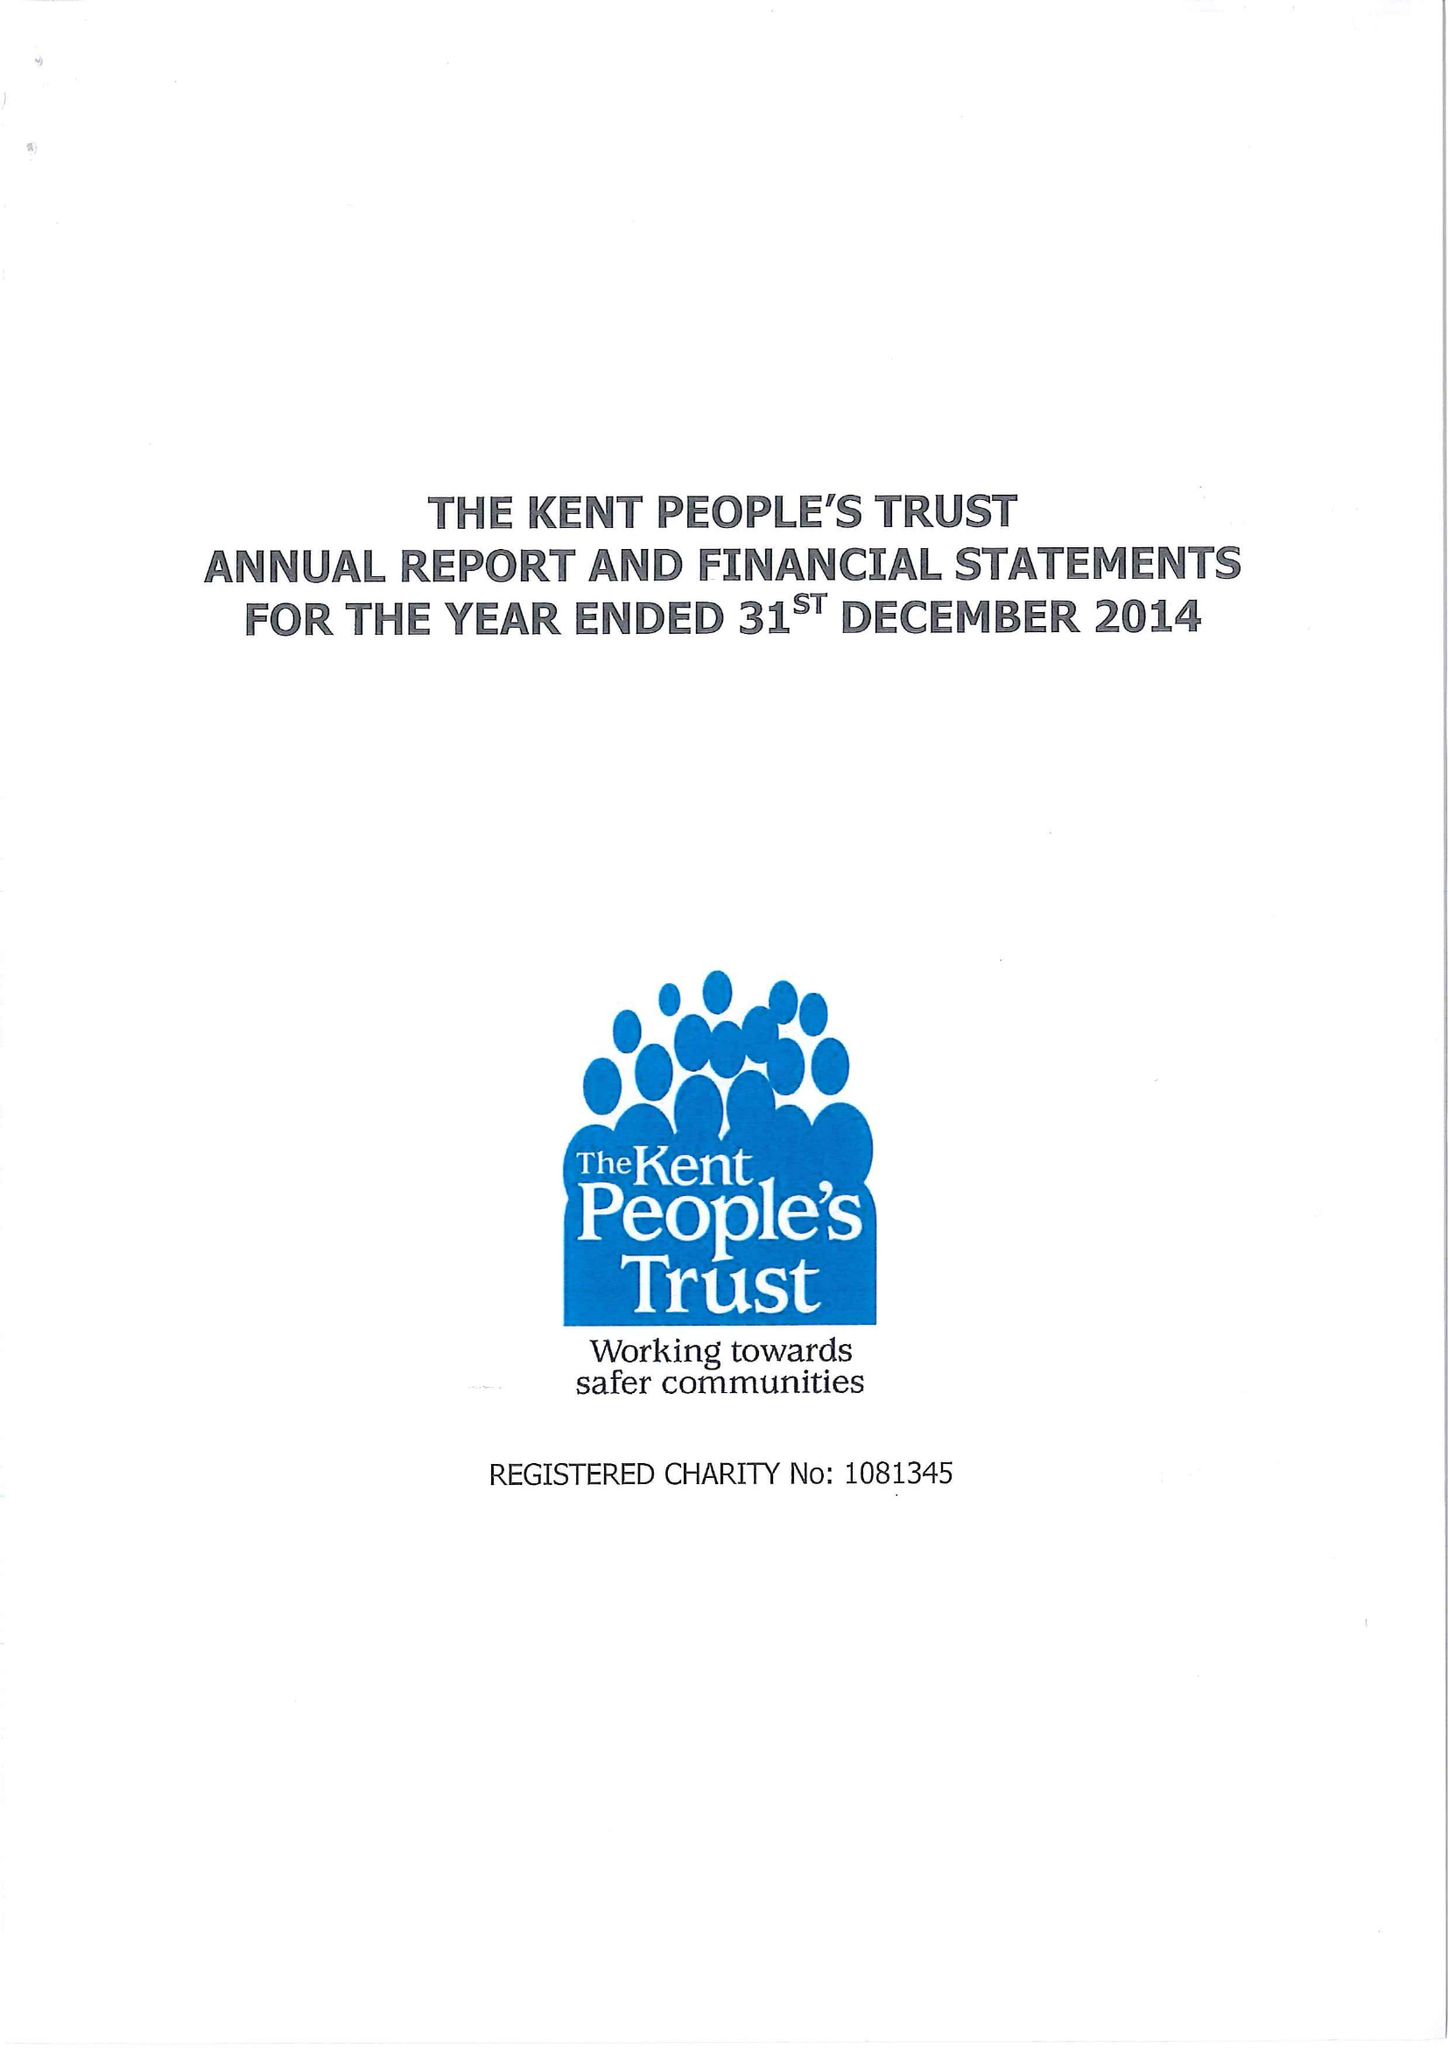What is the value for the address__street_line?
Answer the question using a single word or phrase. SUTTON ROAD 